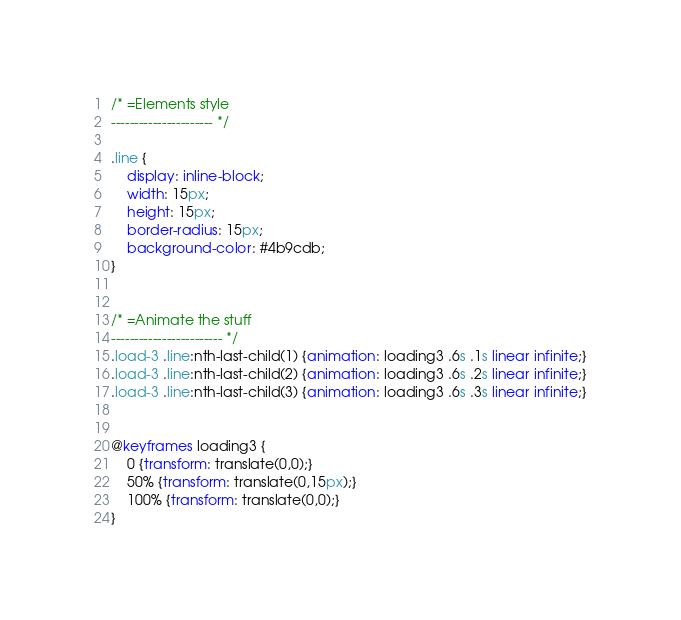Convert code to text. <code><loc_0><loc_0><loc_500><loc_500><_CSS_>/* =Elements style
---------------------- */

.line {
    display: inline-block;
    width: 15px;
    height: 15px;
    border-radius: 15px;
    background-color: #4b9cdb;
}


/* =Animate the stuff
------------------------ */
.load-3 .line:nth-last-child(1) {animation: loading3 .6s .1s linear infinite;}
.load-3 .line:nth-last-child(2) {animation: loading3 .6s .2s linear infinite;}
.load-3 .line:nth-last-child(3) {animation: loading3 .6s .3s linear infinite;}


@keyframes loading3 {
    0 {transform: translate(0,0);}
    50% {transform: translate(0,15px);}
    100% {transform: translate(0,0);}
}

</code> 